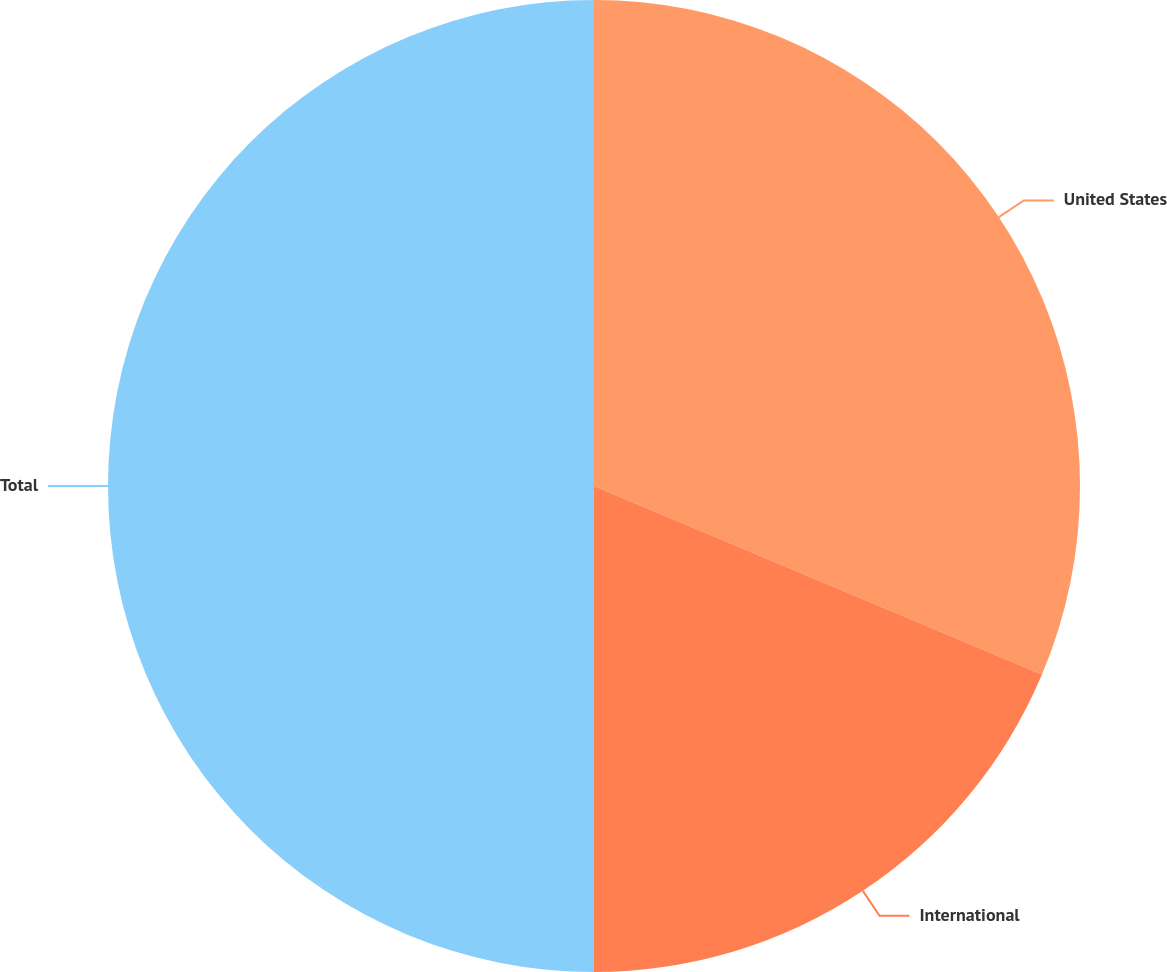Convert chart to OTSL. <chart><loc_0><loc_0><loc_500><loc_500><pie_chart><fcel>United States<fcel>International<fcel>Total<nl><fcel>31.34%<fcel>18.66%<fcel>50.0%<nl></chart> 